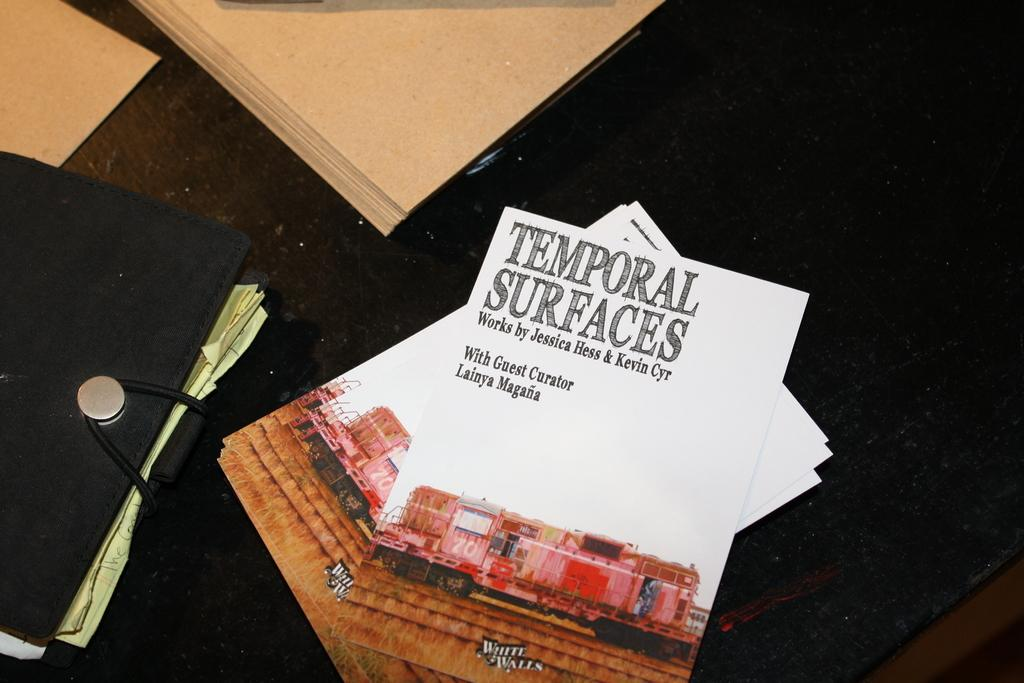What is the color of the pamphlets in the image? The pamphlets in the image are white. What other object can be seen in the image besides the pamphlets? There is a file in the image. What does the earthquake cause the pamphlets to do in the image? There is no earthquake present in the image, so the pamphlets are not affected by any such event. 